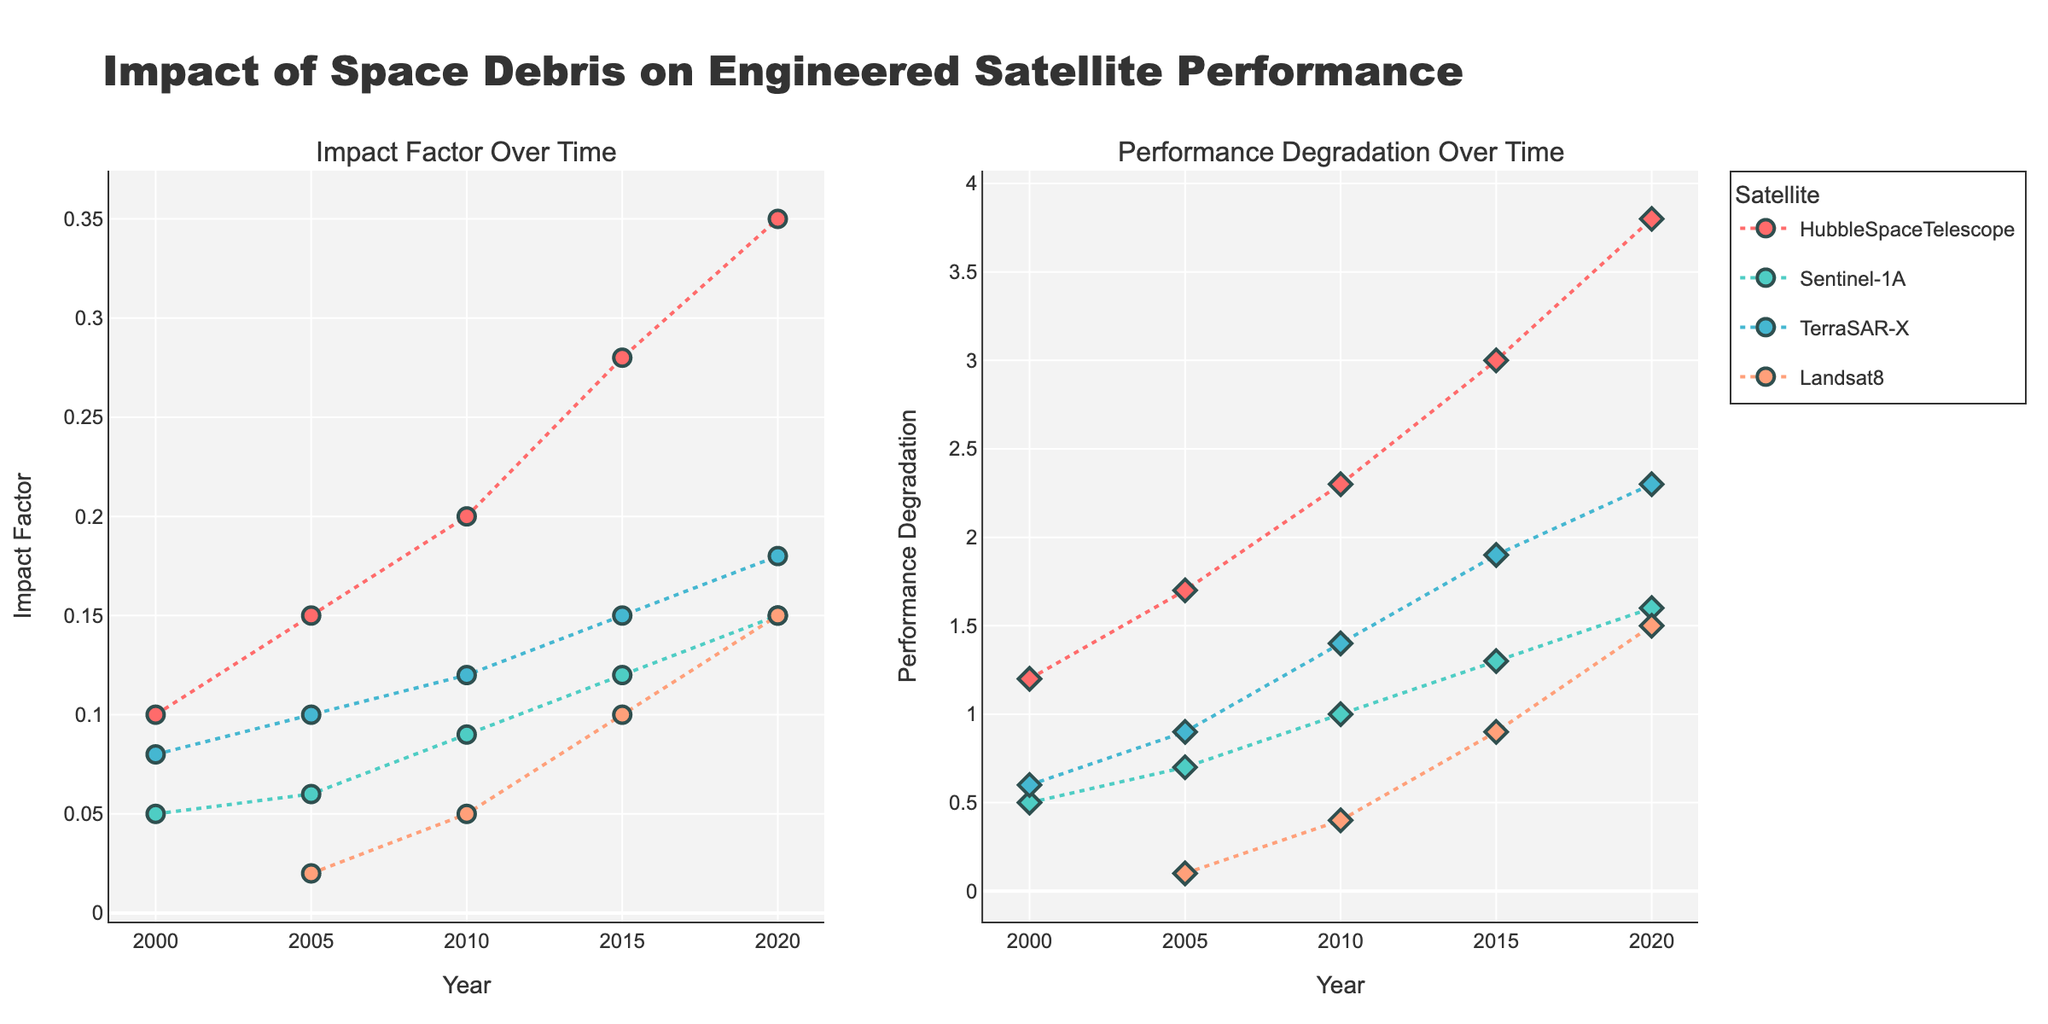What is the title of the figure? The title is located at the top of the figure and it reads "Impact of Space Debris on Engineered Satellite Performance". This indicates the overall theme of the figure.
Answer: Impact of Space Debris on Engineered Satellite Performance How many subplots are in the figure? The figure is divided into two parts side-by-side, showing two different aspects: "Impact Factor Over Time" and "Performance Degradation Over Time". This setup is visible through the titles above each subplot.
Answer: 2 Which satellite shows the highest impact factor in 2020? By looking at the first subplot, you notice that the highest point on the y-axis for the year 2020 corresponds to the "HubbleSpaceTelescope" with an impact factor of 0.35.
Answer: HubbleSpaceTelescope How does the performance degradation of Landsat8 change from 2005 to 2020? Inspect the second subplot. For Landsat8, the performance degradation increases from 0.1 in 2005 to 1.5 in 2020. Custom color coding helps in easily differentiating the satellite data points.
Answer: Increases from 0.1 to 1.5 What is the trend of the impact factor for TerraSAR-X over time? Observing the plot lines in the first subplot for TerraSAR-X, you see a gradual increase in the impact factor from 0.08 in 2000 to 0.18 in 2020. The markers joined by dashed lines show an upward trend.
Answer: Gradual increase Which satellite has the least performance degradation across all years? In the second subplot, look for the satellite with the lowest points across all years. Landsat8 shows the least degradation, particularly visible in 2005 (0.1) compared to others.
Answer: Landsat8 Is there a relationship between the impact factor and performance degradation for any satellite? To determine this, compare respective markers and trend lines in both subplots for a specific satellite, like HubbleSpaceTelescope. An increase in impact factor often corresponds to higher performance degradation, observed by rising trends in both subplots.
Answer: Yes, rising trends What is the average impact factor for Sentinel-1A over the given years? Identify the impact factors for Sentinel-1A in the first subplot: 0.05, 0.06, 0.09, 0.12, and 0.15. Sum these values (0.47) and divide by the number of points (5) to get the average: 0.47/5 = 0.094.
Answer: 0.094 Which satellite exhibits the greatest increase in performance degradation from 2010 to 2020? Look at the second subplot and compare the performance degradation values. For HubbleSpaceTelescope, it increases from 2.3 (2010) to 3.8 (2020), a change of 1.5, whereas others show smaller changes.
Answer: HubbleSpaceTelescope How do the trends in impact factor and performance degradation for Sentinel-1A compare? In both subplots, Sentinel-1A shows increasing trends. For Impact Factor: 0.05 to 0.15 and Performance Degradation: 0.5 to 1.6 over the years. This parallel growth indicates a correlation.
Answer: Both increase 